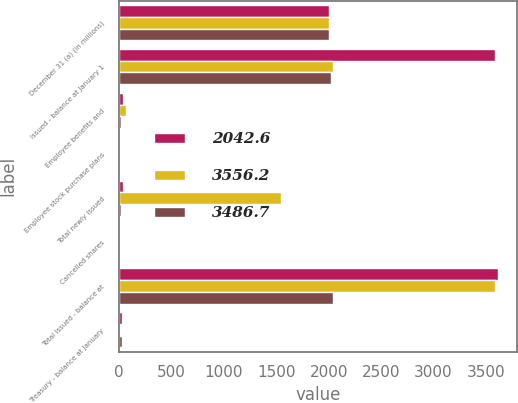Convert chart. <chart><loc_0><loc_0><loc_500><loc_500><stacked_bar_chart><ecel><fcel>December 31 (a) (in millions)<fcel>Issued - balance at January 1<fcel>Employee benefits and<fcel>Employee stock purchase plans<fcel>Total newly issued<fcel>Cancelled shares<fcel>Total issued - balance at<fcel>Treasury - balance at January<nl><fcel>2042.6<fcel>2005<fcel>3584.8<fcel>34<fcel>1.4<fcel>35.4<fcel>2<fcel>3618.2<fcel>28.6<nl><fcel>3556.2<fcel>2004<fcel>2044.4<fcel>69<fcel>3.1<fcel>1541.5<fcel>1.1<fcel>3584.8<fcel>1.8<nl><fcel>3486.7<fcel>2003<fcel>2023.6<fcel>20.9<fcel>0.7<fcel>21.6<fcel>0.8<fcel>2044.4<fcel>24.9<nl></chart> 